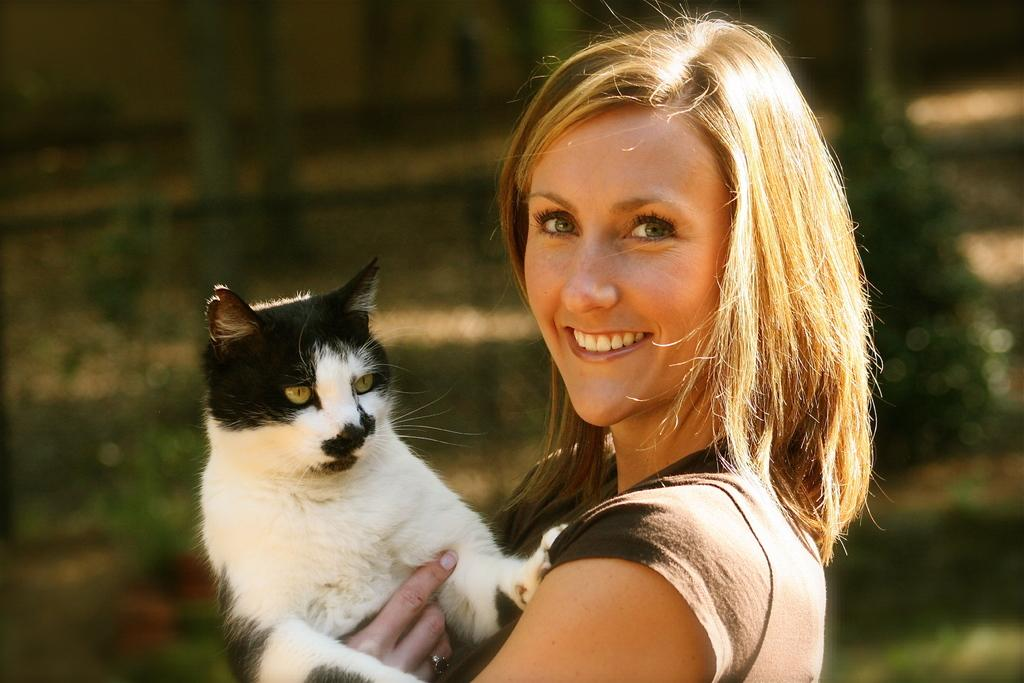What is the main subject of the image? The main subject of the image is a woman. What is the woman holding in the image? The woman is holding a cat. Can you describe the appearance of the cat? The cat is black and white in color. What is the woman's facial expression in the image? The woman is smiling. How would you describe the background of the image? The background of the image is blurred. How many cards can be seen in the image? There are no cards present in the image. Is the woman in the image sinking into quicksand? There is no quicksand present in the image, and the woman is not sinking. 